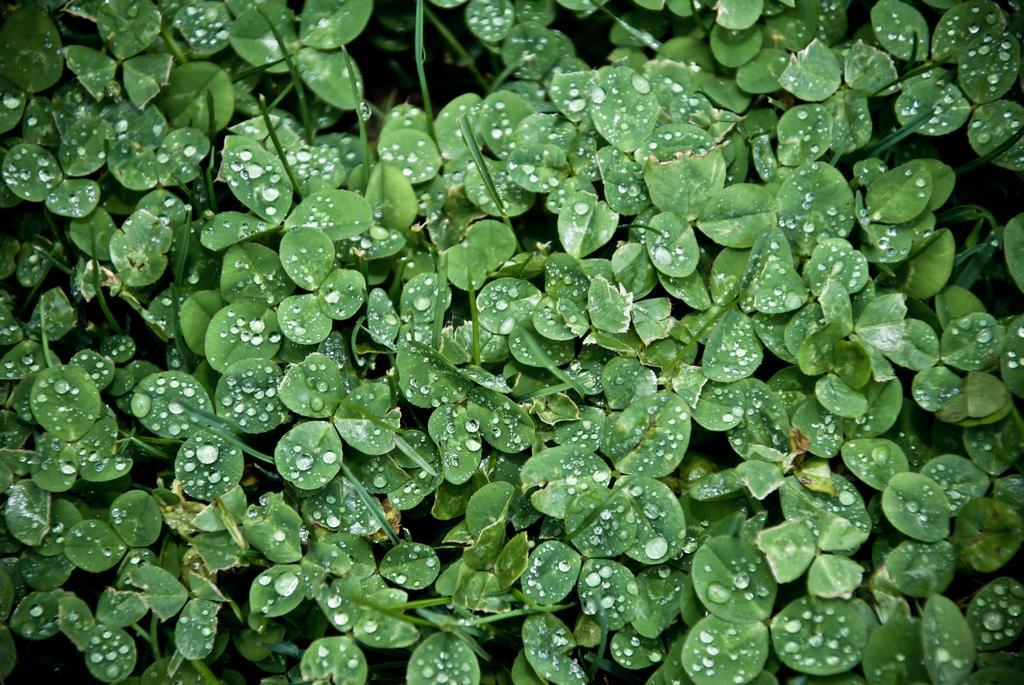Describe this image in one or two sentences. In this picture we can see leaves of the plants, there are some water drops on these leaves. 